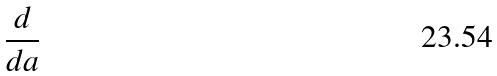<formula> <loc_0><loc_0><loc_500><loc_500>\frac { d } { d a }</formula> 